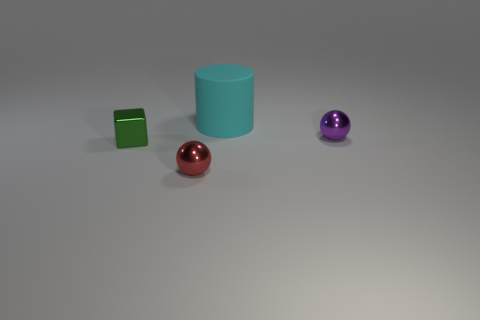Add 2 red shiny spheres. How many objects exist? 6 Subtract all cylinders. How many objects are left? 3 Subtract 0 gray spheres. How many objects are left? 4 Subtract all small green things. Subtract all cylinders. How many objects are left? 2 Add 4 metallic cubes. How many metallic cubes are left? 5 Add 2 shiny cubes. How many shiny cubes exist? 3 